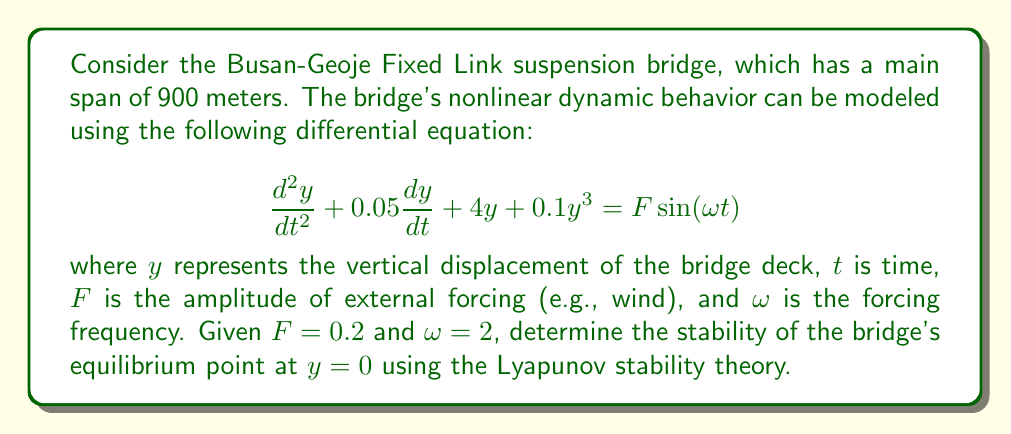What is the answer to this math problem? To analyze the stability of the equilibrium point using Lyapunov stability theory, we'll follow these steps:

1) First, rewrite the equation as a system of first-order differential equations:
   Let $x_1 = y$ and $x_2 = \frac{dy}{dt}$. Then:
   
   $$\frac{dx_1}{dt} = x_2$$
   $$\frac{dx_2}{dt} = -0.05x_2 - 4x_1 - 0.1x_1^3 + 0.2\sin(2t)$$

2) The equilibrium point $(x_1, x_2) = (0, 0)$ corresponds to the bridge at rest.

3) Choose a Lyapunov function candidate:
   $$V(x_1, x_2) = 2x_1^2 + x_2^2$$

4) Calculate the time derivative of V:
   
   $$\frac{dV}{dt} = 4x_1\frac{dx_1}{dt} + 2x_2\frac{dx_2}{dt}$$
   $$= 4x_1x_2 + 2x_2(-0.05x_2 - 4x_1 - 0.1x_1^3 + 0.2\sin(2t))$$
   $$= -0.1x_2^2 - 4x_1^2 - 0.2x_1^3x_2 + 0.4x_2\sin(2t)$$

5) To prove stability, we need to show that $\frac{dV}{dt} < 0$ in some neighborhood of the origin, excluding the forcing term.

6) Without the forcing term:
   $$\frac{dV}{dt} = -0.1x_2^2 - 4x_1^2 - 0.2x_1^3x_2$$

7) This is negative definite in some neighborhood of the origin, as the first two terms are always negative and the third term is of higher order.

8) However, with the forcing term $0.4x_2\sin(2t)$, the system is non-autonomous and may exhibit periodic behavior.

9) The forcing term is bounded by $|0.4x_2\sin(2t)| \leq 0.4|x_2|$. If $|x_2| > 1$, then the negative terms will dominate, ensuring $\frac{dV}{dt} < 0$.

10) Therefore, the system is stable in the sense of Lyapunov, but not asymptotically stable due to the periodic forcing.
Answer: Stable in the sense of Lyapunov, but not asymptotically stable. 